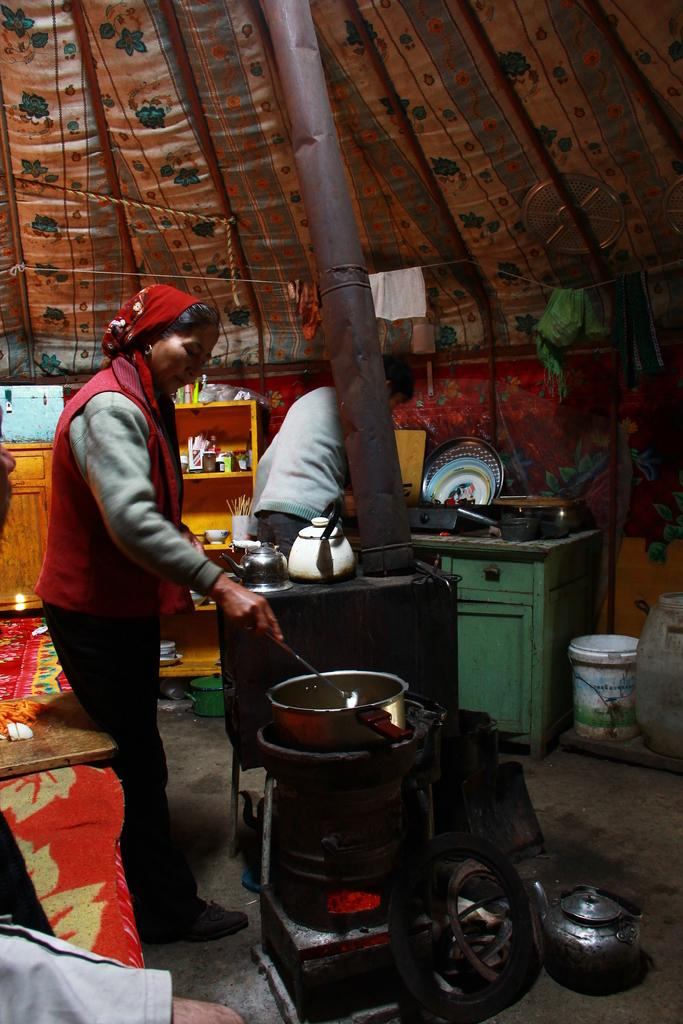What is the person in the image holding? The person in the image is holding a spoon. What can be seen in the background of the image? There is a stove in the image. What is on the table in the image? There are vessels on a table in the image. What is on the floor in the image? There are objects on the floor in the image. What color is the cupboard in the image? There is a yellow color cupboard in the image. What is inside the yellow color cupboard? There are objects inside the yellow color cupboard. Can you see any goldfish swimming in the yellow color cupboard in the image? No, there are no goldfish present in the image, and the yellow color cupboard is not a body of water where fish could swim. 